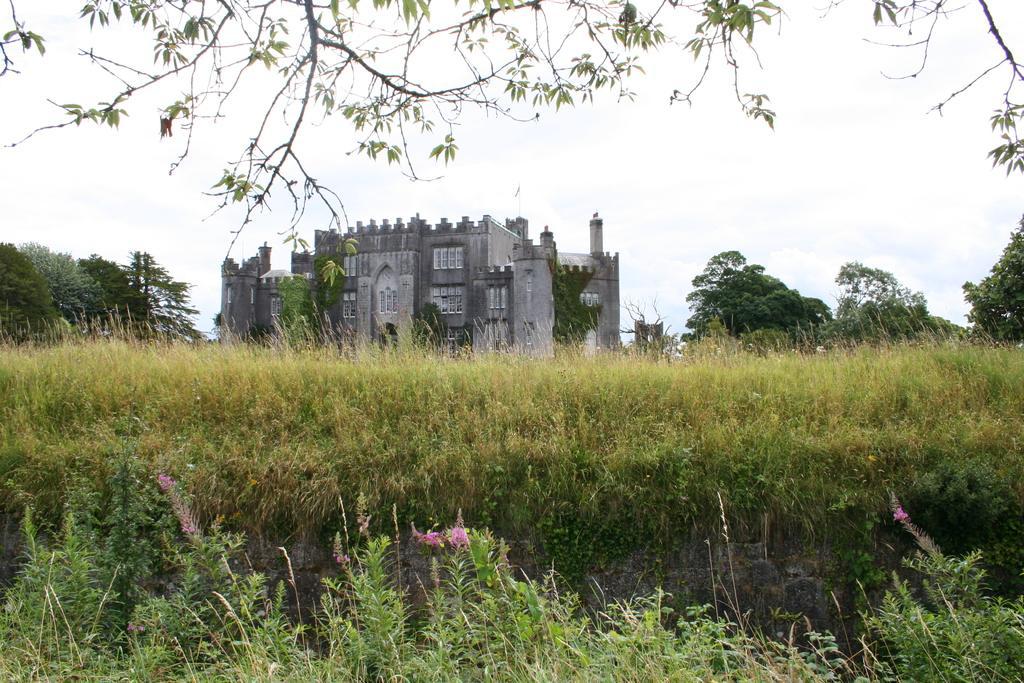In one or two sentences, can you explain what this image depicts? In this image in front there are trees. At the bottom of the image there is grass on the grass. In the background of the image there are trees. There is a building and sky. 